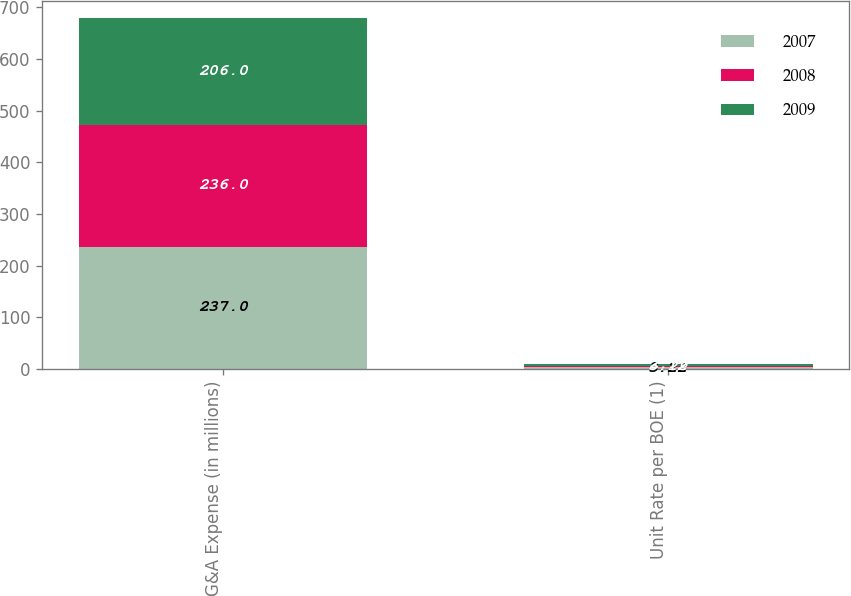<chart> <loc_0><loc_0><loc_500><loc_500><stacked_bar_chart><ecel><fcel>G&A Expense (in millions)<fcel>Unit Rate per BOE (1)<nl><fcel>2007<fcel>237<fcel>3.22<nl><fcel>2008<fcel>236<fcel>3.12<nl><fcel>2009<fcel>206<fcel>2.96<nl></chart> 